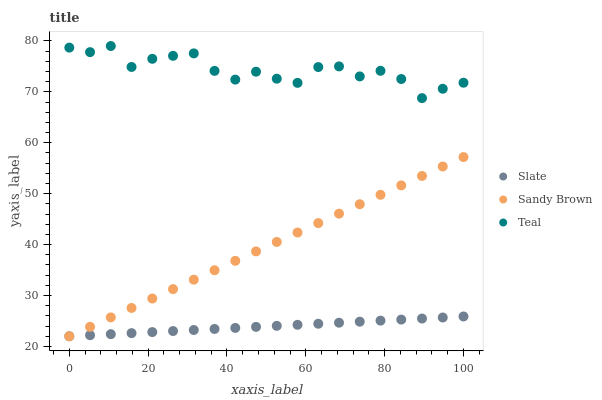Does Slate have the minimum area under the curve?
Answer yes or no. Yes. Does Teal have the maximum area under the curve?
Answer yes or no. Yes. Does Sandy Brown have the minimum area under the curve?
Answer yes or no. No. Does Sandy Brown have the maximum area under the curve?
Answer yes or no. No. Is Slate the smoothest?
Answer yes or no. Yes. Is Teal the roughest?
Answer yes or no. Yes. Is Sandy Brown the smoothest?
Answer yes or no. No. Is Sandy Brown the roughest?
Answer yes or no. No. Does Slate have the lowest value?
Answer yes or no. Yes. Does Teal have the lowest value?
Answer yes or no. No. Does Teal have the highest value?
Answer yes or no. Yes. Does Sandy Brown have the highest value?
Answer yes or no. No. Is Slate less than Teal?
Answer yes or no. Yes. Is Teal greater than Slate?
Answer yes or no. Yes. Does Sandy Brown intersect Slate?
Answer yes or no. Yes. Is Sandy Brown less than Slate?
Answer yes or no. No. Is Sandy Brown greater than Slate?
Answer yes or no. No. Does Slate intersect Teal?
Answer yes or no. No. 